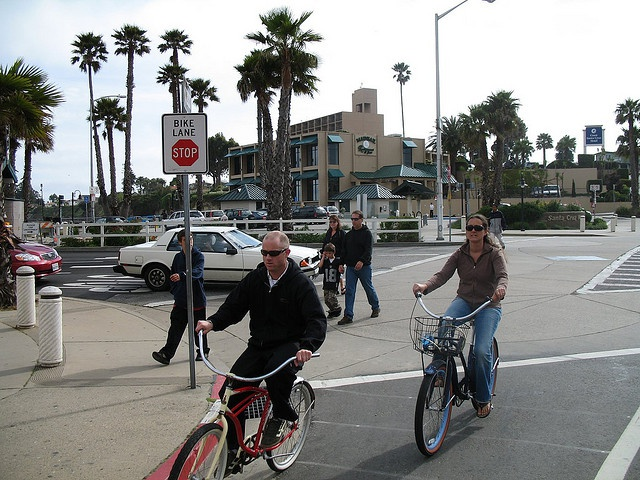Describe the objects in this image and their specific colors. I can see people in lightblue, black, gray, maroon, and darkgray tones, bicycle in lightblue, black, gray, darkgray, and maroon tones, bicycle in lightblue, black, gray, darkgray, and navy tones, car in lightblue, darkgray, black, gray, and white tones, and people in lightblue, black, gray, and blue tones in this image. 